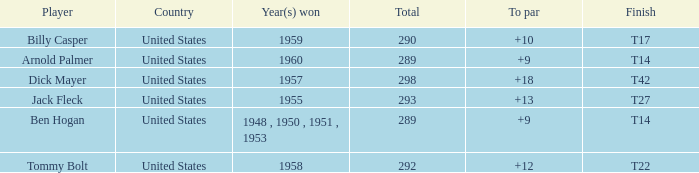What is the total number of Total, when To Par is 12? 1.0. 